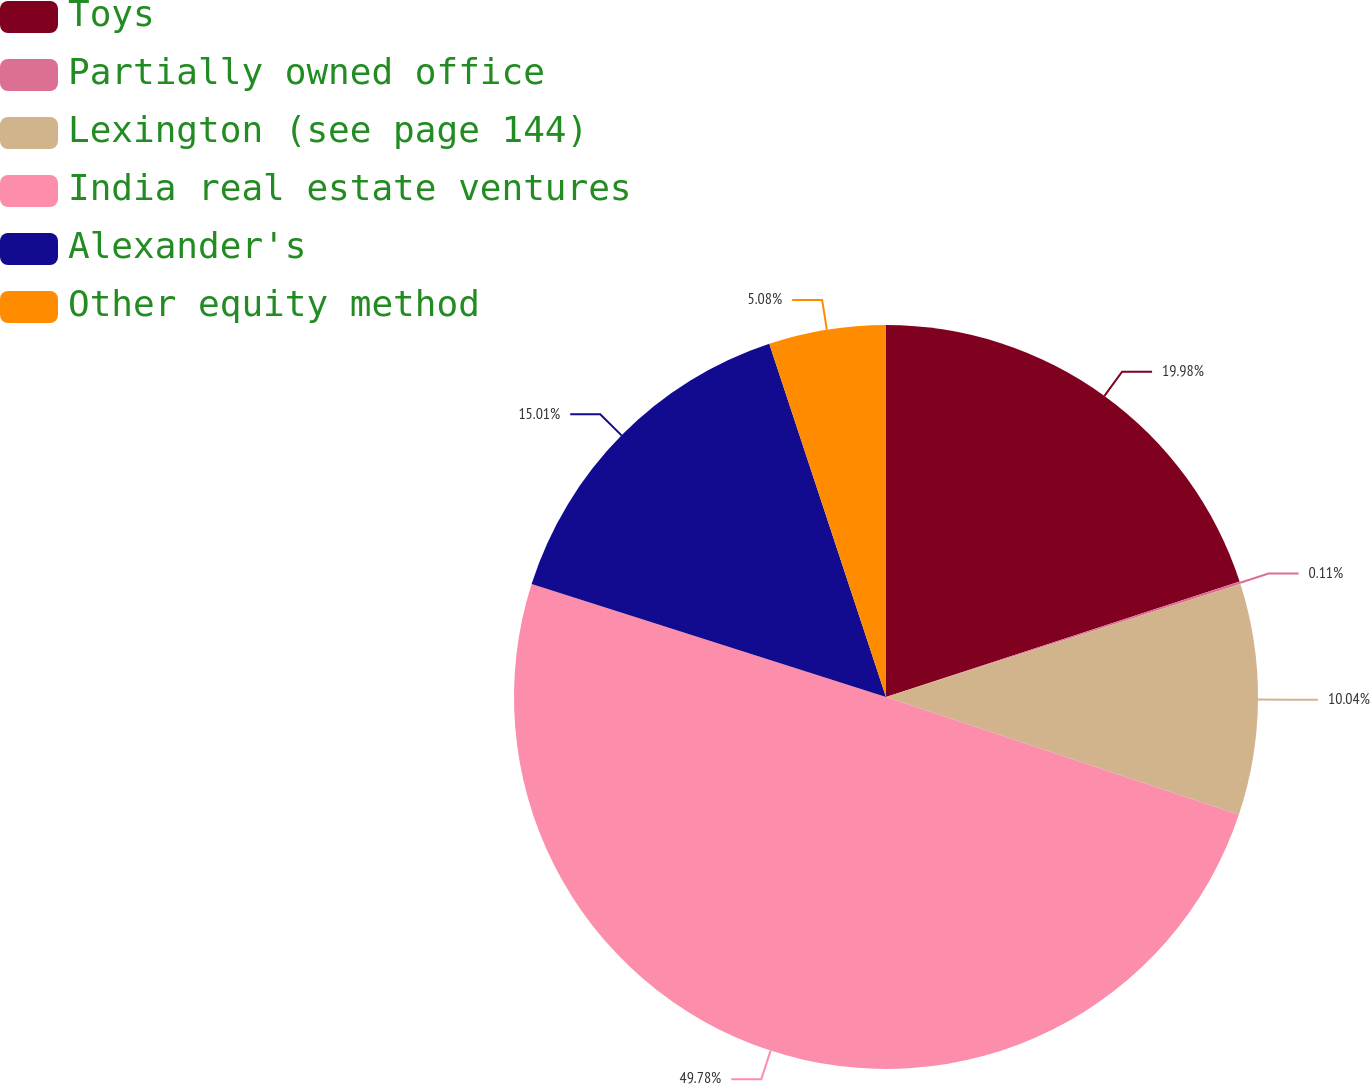<chart> <loc_0><loc_0><loc_500><loc_500><pie_chart><fcel>Toys<fcel>Partially owned office<fcel>Lexington (see page 144)<fcel>India real estate ventures<fcel>Alexander's<fcel>Other equity method<nl><fcel>19.98%<fcel>0.11%<fcel>10.04%<fcel>49.78%<fcel>15.01%<fcel>5.08%<nl></chart> 